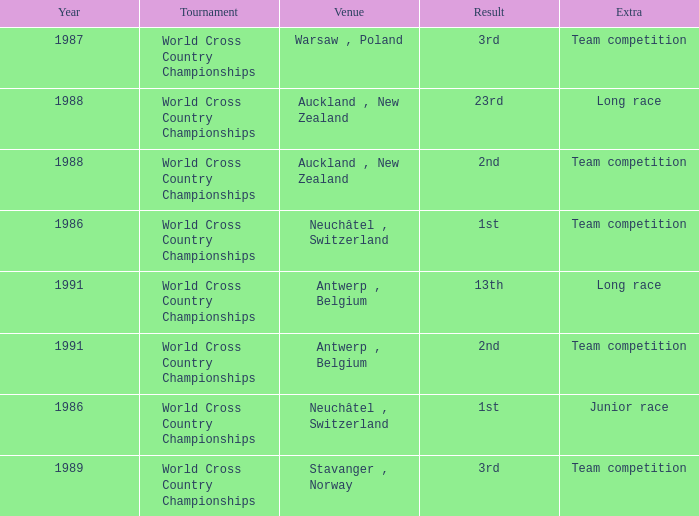Which venue had an extra of Team Competition and a result of 1st? Neuchâtel , Switzerland. 